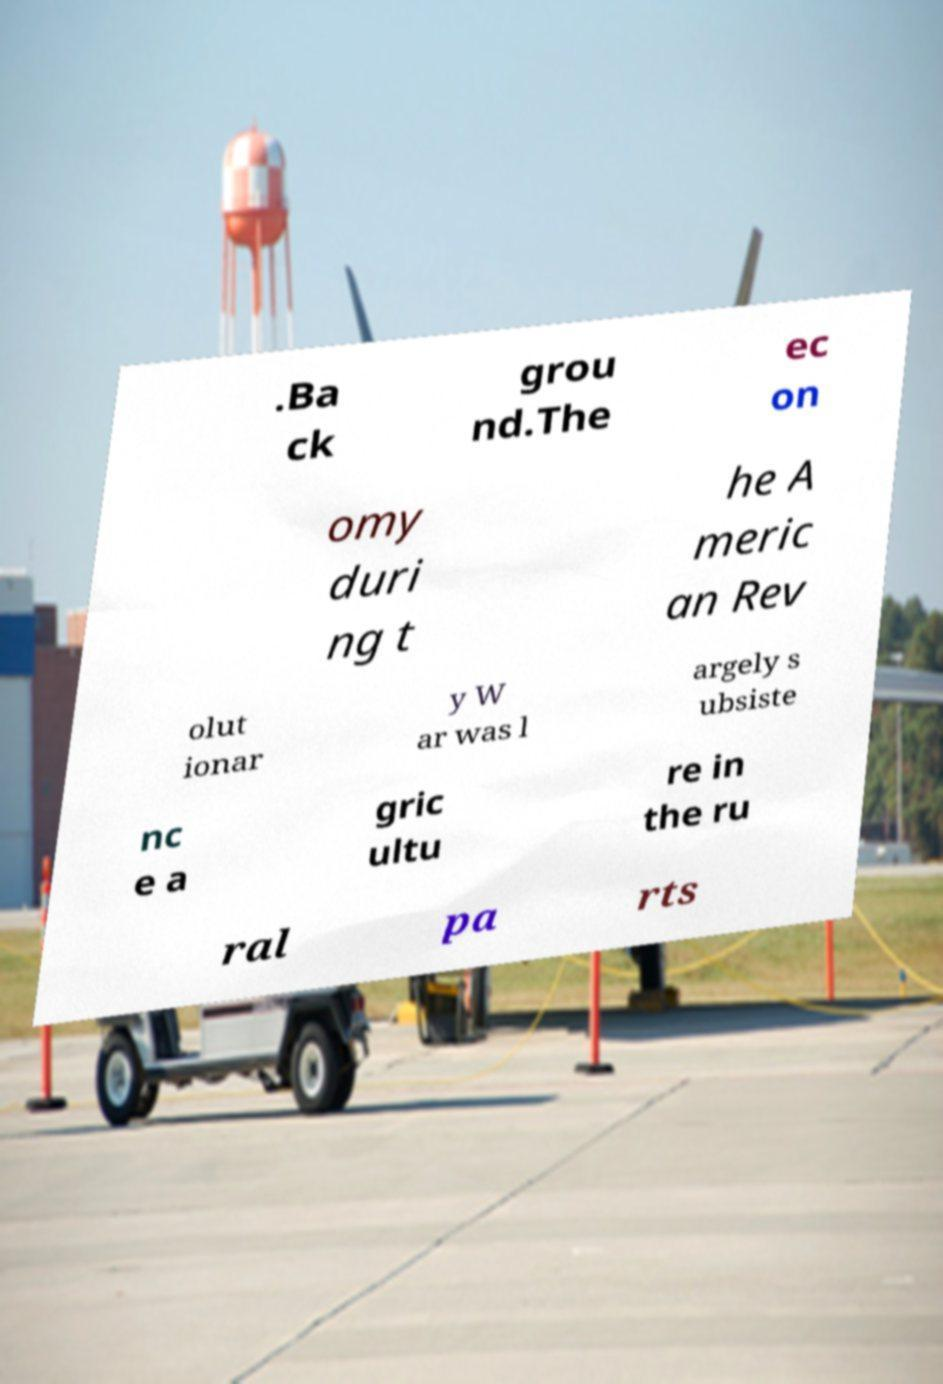What messages or text are displayed in this image? I need them in a readable, typed format. .Ba ck grou nd.The ec on omy duri ng t he A meric an Rev olut ionar y W ar was l argely s ubsiste nc e a gric ultu re in the ru ral pa rts 